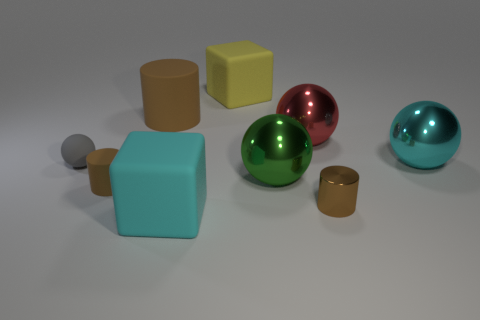Can you describe the shapes and colors in the image? Certainly. The image presents a variety of geometric shapes in different colors. We have a cyan-colored ball, a yellow cube, and a red sphere, alongside a green sphere, a teal cuboid, and two cylinders—one gold and one silver. The distribution of shapes and colors creates a visually interesting composition. 